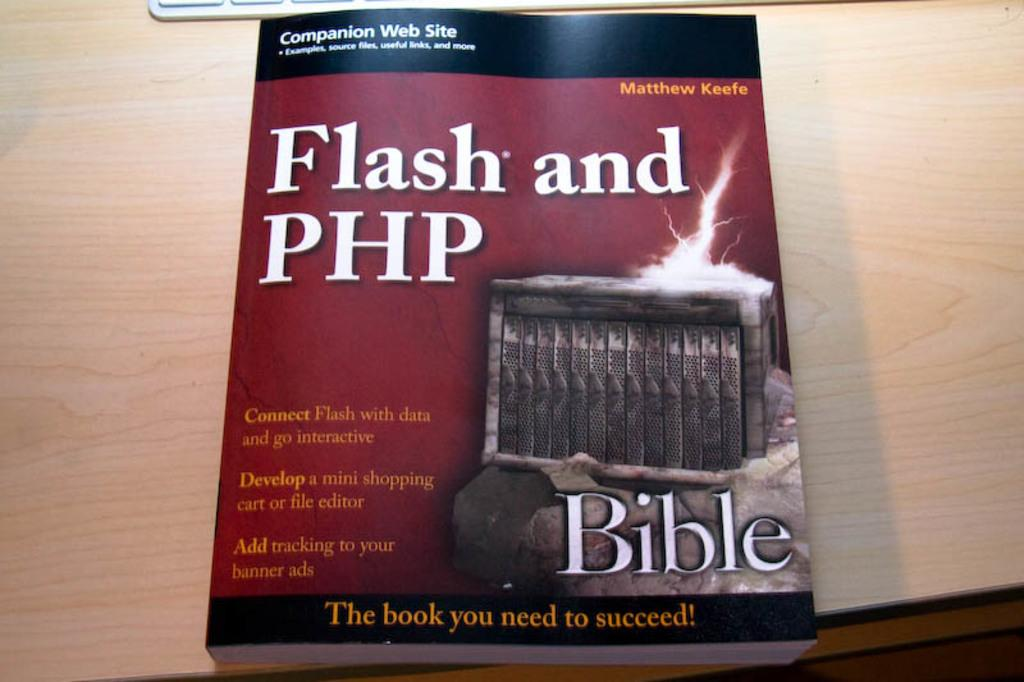<image>
Describe the image concisely. The textbook called Flash and PHP is on a desk 